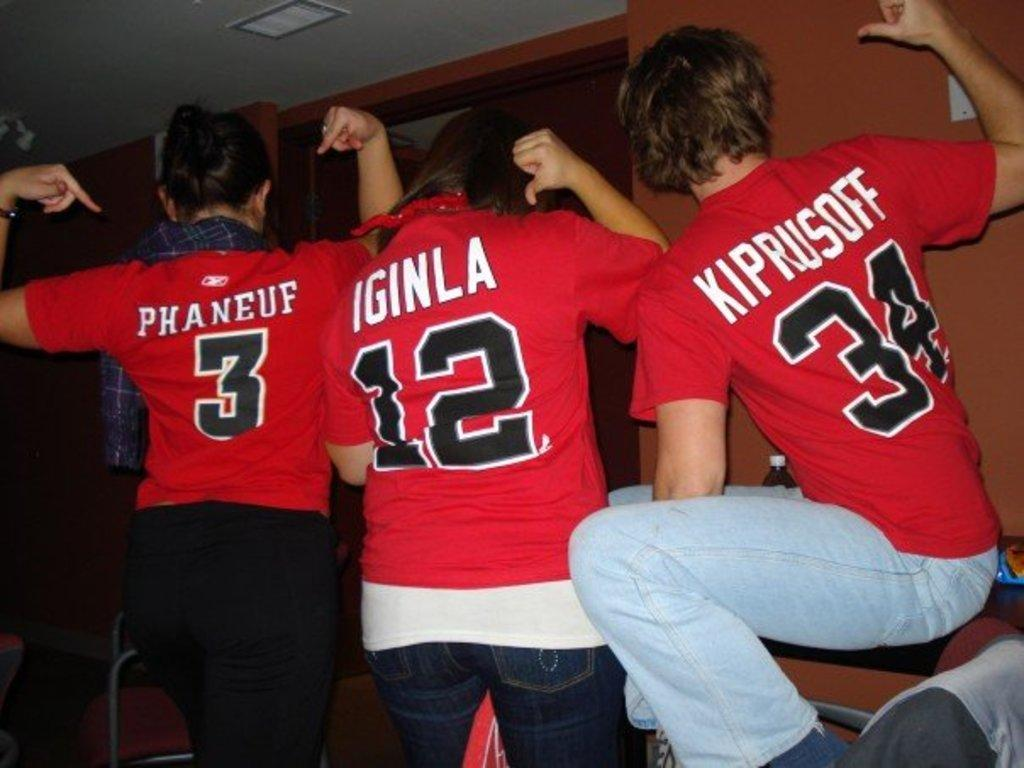Provide a one-sentence caption for the provided image. Three people wearing jerseys with the digits 3 12 34. 